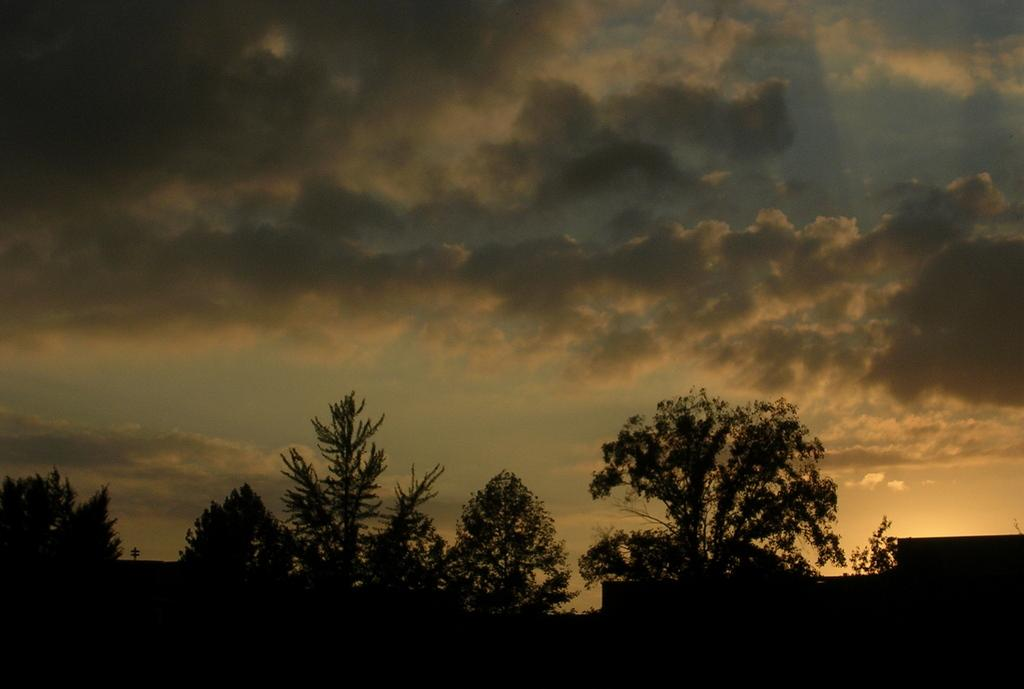What type of vegetation can be seen in the image? There are trees in the image. What part of the natural environment is visible in the image? The sky is visible in the image. How would you describe the sky in the image? The sky appears to be cloudy in the image. How would you describe the overall lighting in the image? The image appears to be dark. Can you see a bubble floating in the image? There is no bubble present in the image. Is there a door visible in the image? There is no door mentioned or visible in the image. 